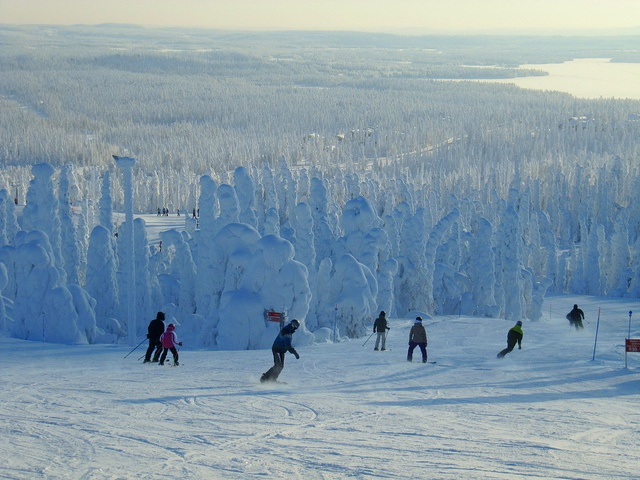Describe the objects in this image and their specific colors. I can see people in lightgray, black, navy, and gray tones, people in lightgray, black, navy, blue, and gray tones, people in lightgray, black, navy, blue, and gray tones, people in lightgray, black, navy, purple, and gray tones, and people in lightgray, black, darkgreen, blue, and navy tones in this image. 